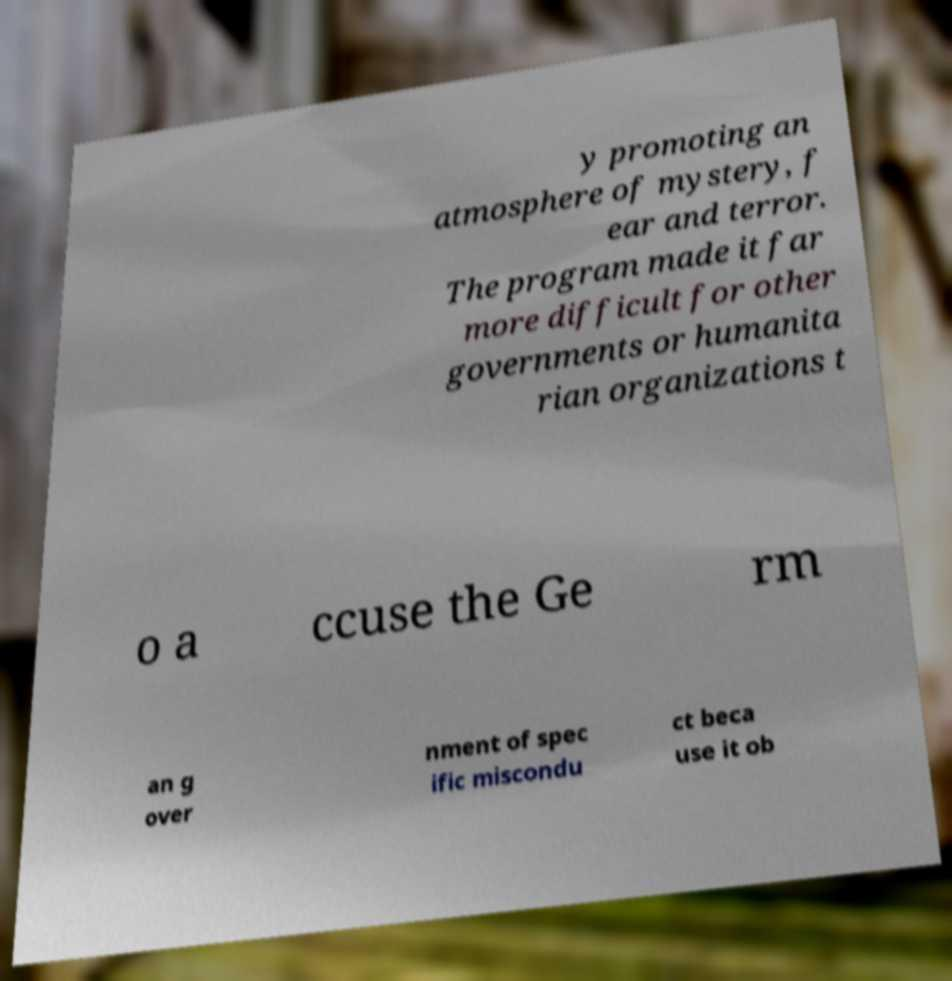I need the written content from this picture converted into text. Can you do that? y promoting an atmosphere of mystery, f ear and terror. The program made it far more difficult for other governments or humanita rian organizations t o a ccuse the Ge rm an g over nment of spec ific miscondu ct beca use it ob 